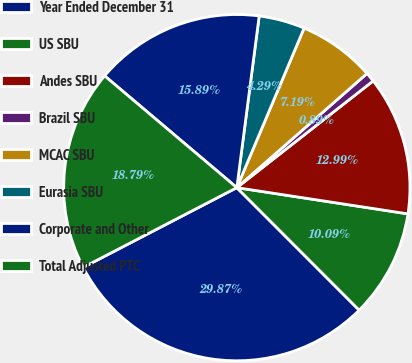Convert chart. <chart><loc_0><loc_0><loc_500><loc_500><pie_chart><fcel>Year Ended December 31<fcel>US SBU<fcel>Andes SBU<fcel>Brazil SBU<fcel>MCAC SBU<fcel>Eurasia SBU<fcel>Corporate and Other<fcel>Total Adjusted PTC<nl><fcel>29.87%<fcel>10.09%<fcel>12.99%<fcel>0.89%<fcel>7.19%<fcel>4.29%<fcel>15.89%<fcel>18.79%<nl></chart> 